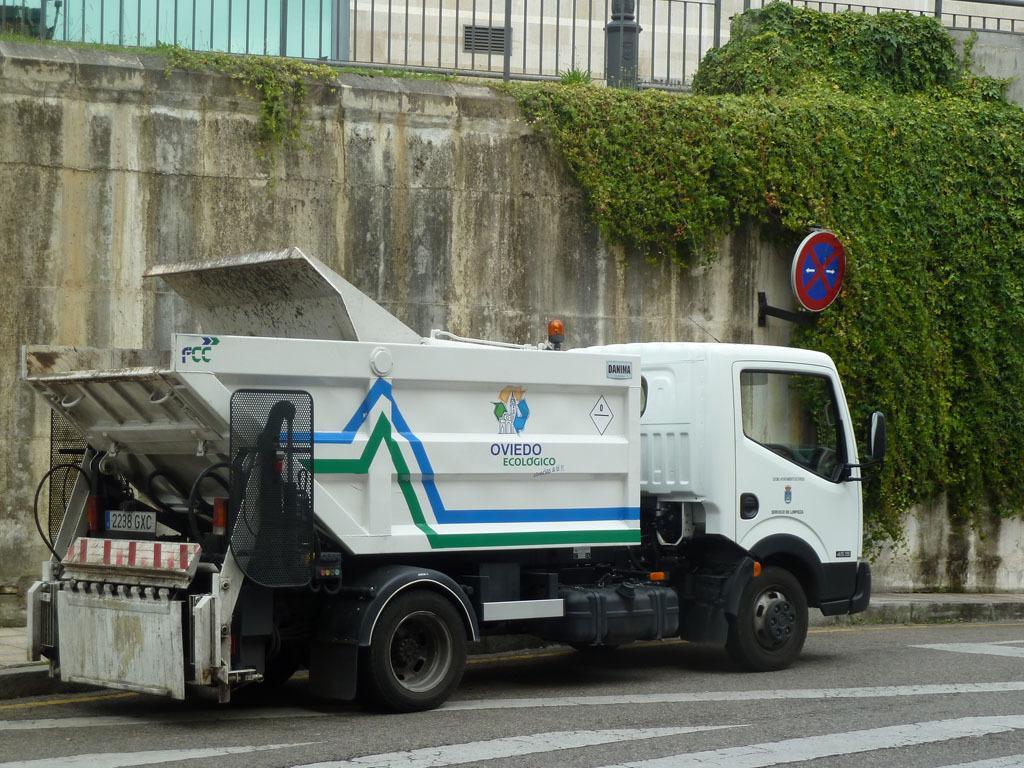Describe this image in one or two sentences. In this image, I can see a truck on the road. There are creeper plants and a sign board to the wall. At the top of the image, I can see the iron grilles. 